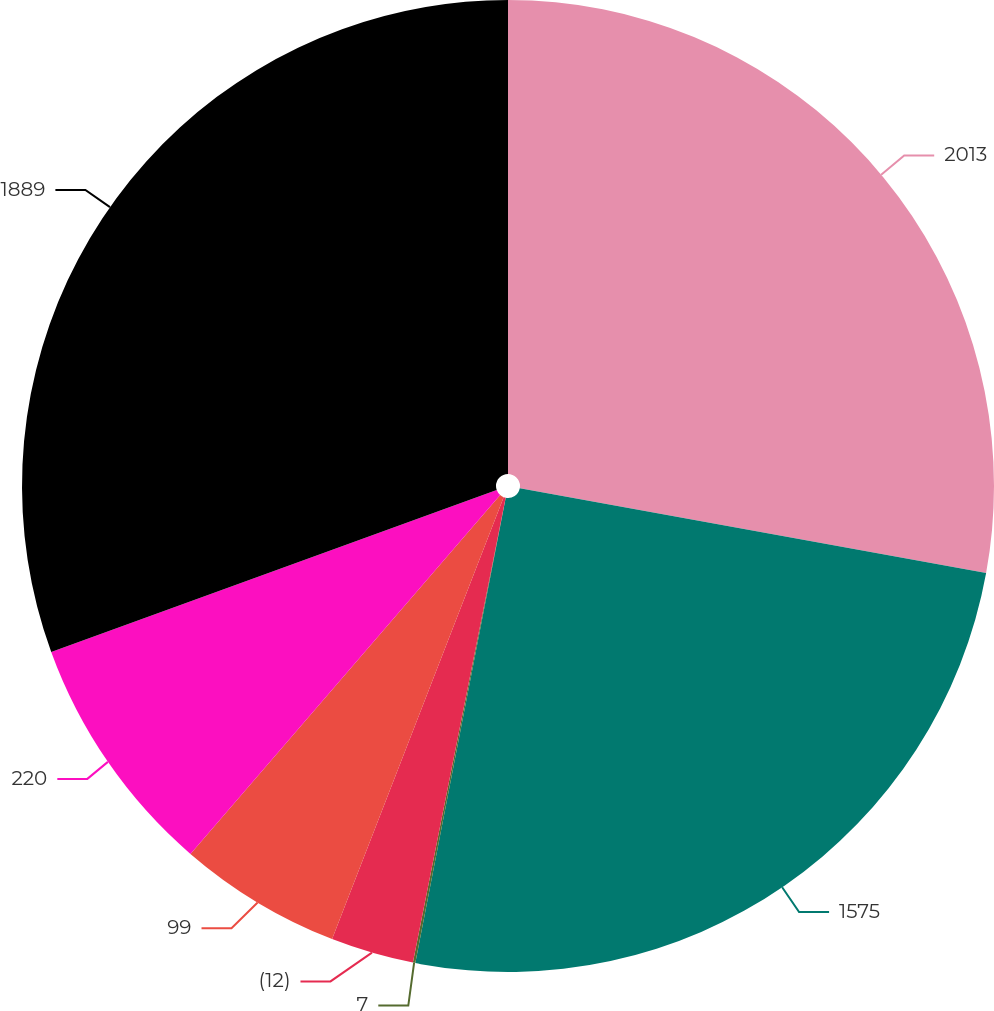Convert chart. <chart><loc_0><loc_0><loc_500><loc_500><pie_chart><fcel>2013<fcel>1575<fcel>7<fcel>(12)<fcel>99<fcel>220<fcel>1889<nl><fcel>27.87%<fcel>25.19%<fcel>0.08%<fcel>2.76%<fcel>5.44%<fcel>8.12%<fcel>30.55%<nl></chart> 